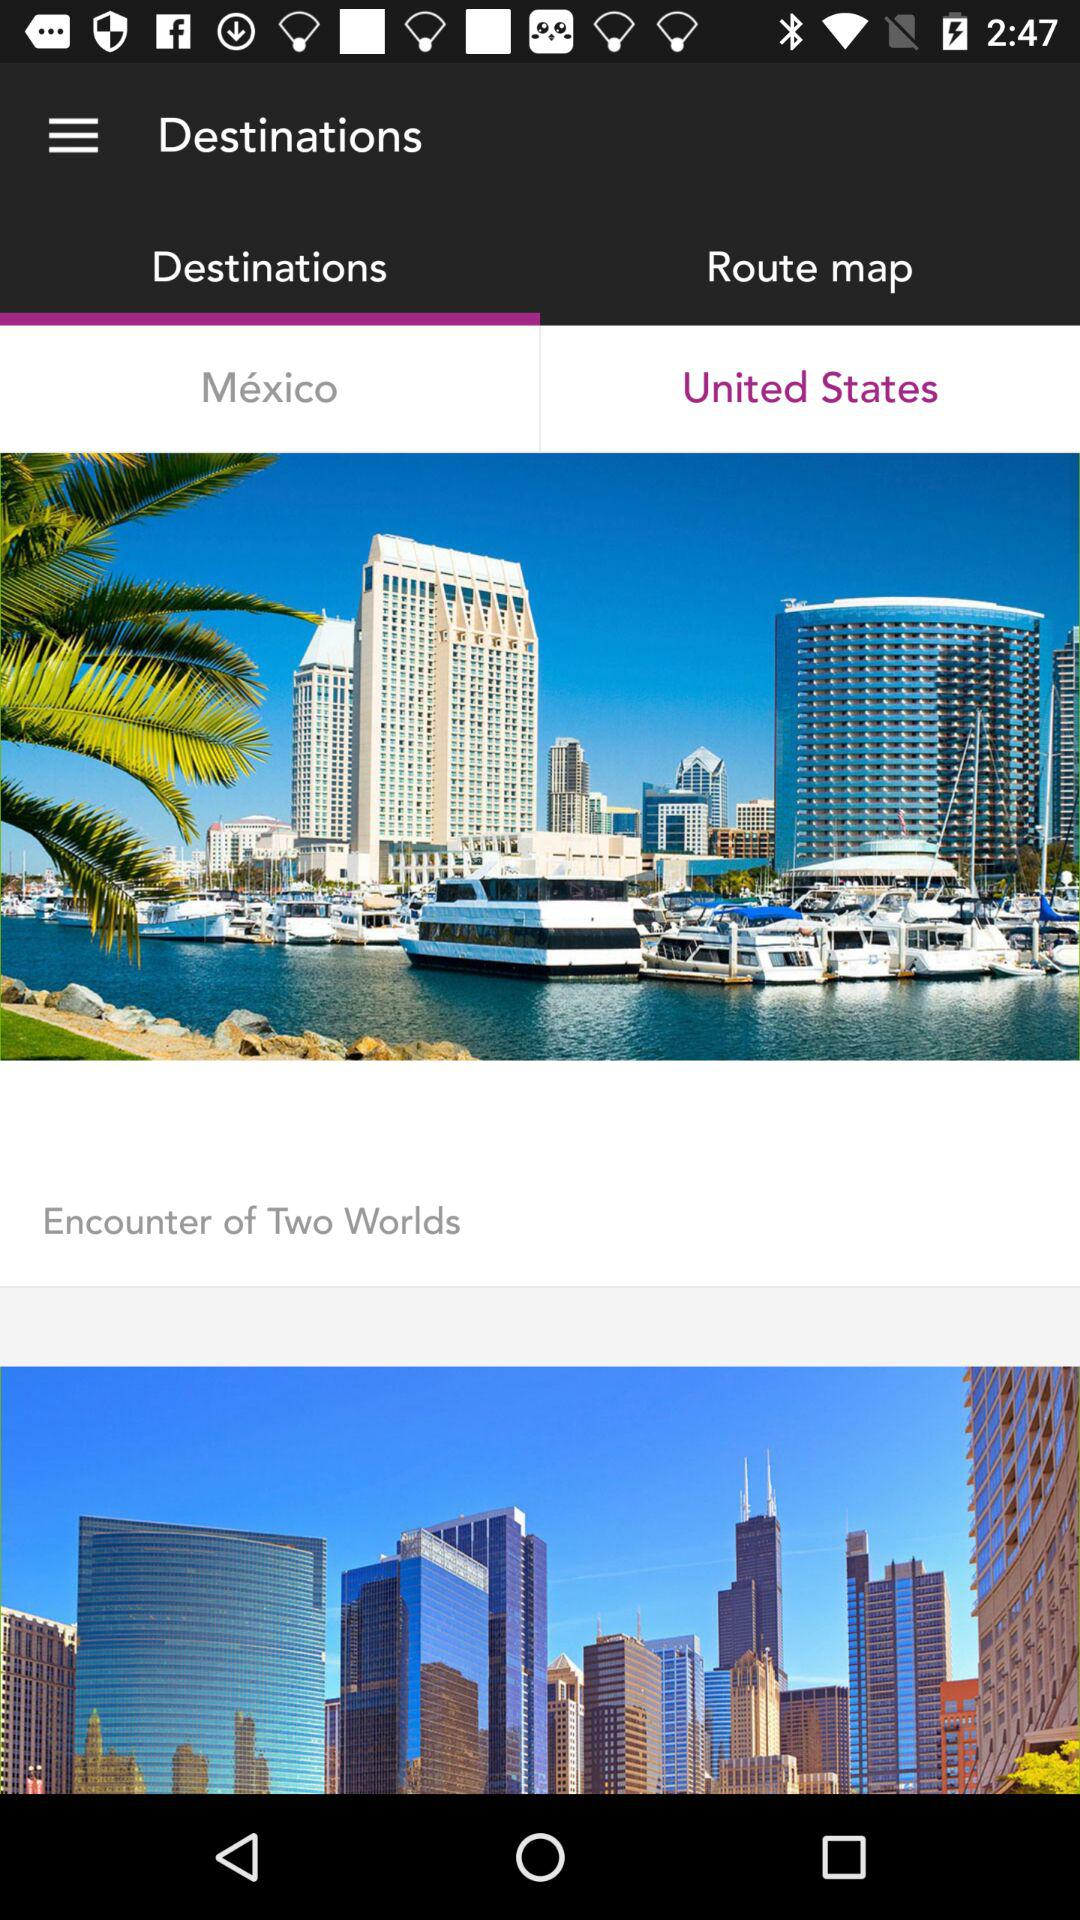Which tab is selected? The selected tab is "Destinations". 